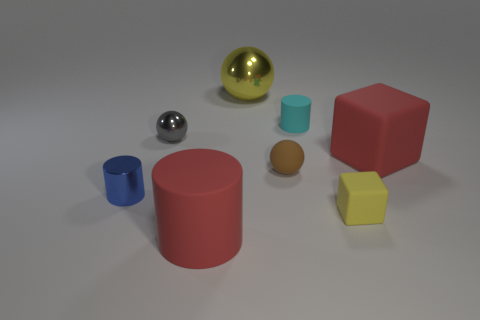Add 2 big matte cylinders. How many objects exist? 10 Subtract all spheres. How many objects are left? 5 Subtract 0 purple cylinders. How many objects are left? 8 Subtract all tiny red rubber things. Subtract all yellow cubes. How many objects are left? 7 Add 6 large shiny spheres. How many large shiny spheres are left? 7 Add 8 tiny gray blocks. How many tiny gray blocks exist? 8 